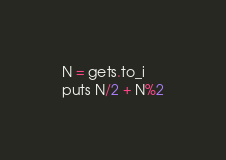Convert code to text. <code><loc_0><loc_0><loc_500><loc_500><_Ruby_>N = gets.to_i
puts N/2 + N%2
</code> 